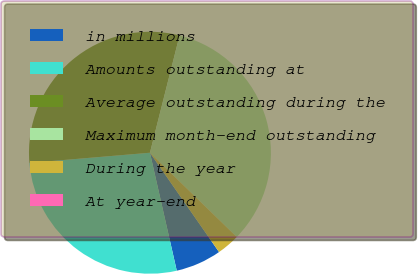Convert chart to OTSL. <chart><loc_0><loc_0><loc_500><loc_500><pie_chart><fcel>in millions<fcel>Amounts outstanding at<fcel>Average outstanding during the<fcel>Maximum month-end outstanding<fcel>During the year<fcel>At year-end<nl><fcel>6.12%<fcel>27.22%<fcel>30.28%<fcel>33.33%<fcel>3.06%<fcel>0.0%<nl></chart> 